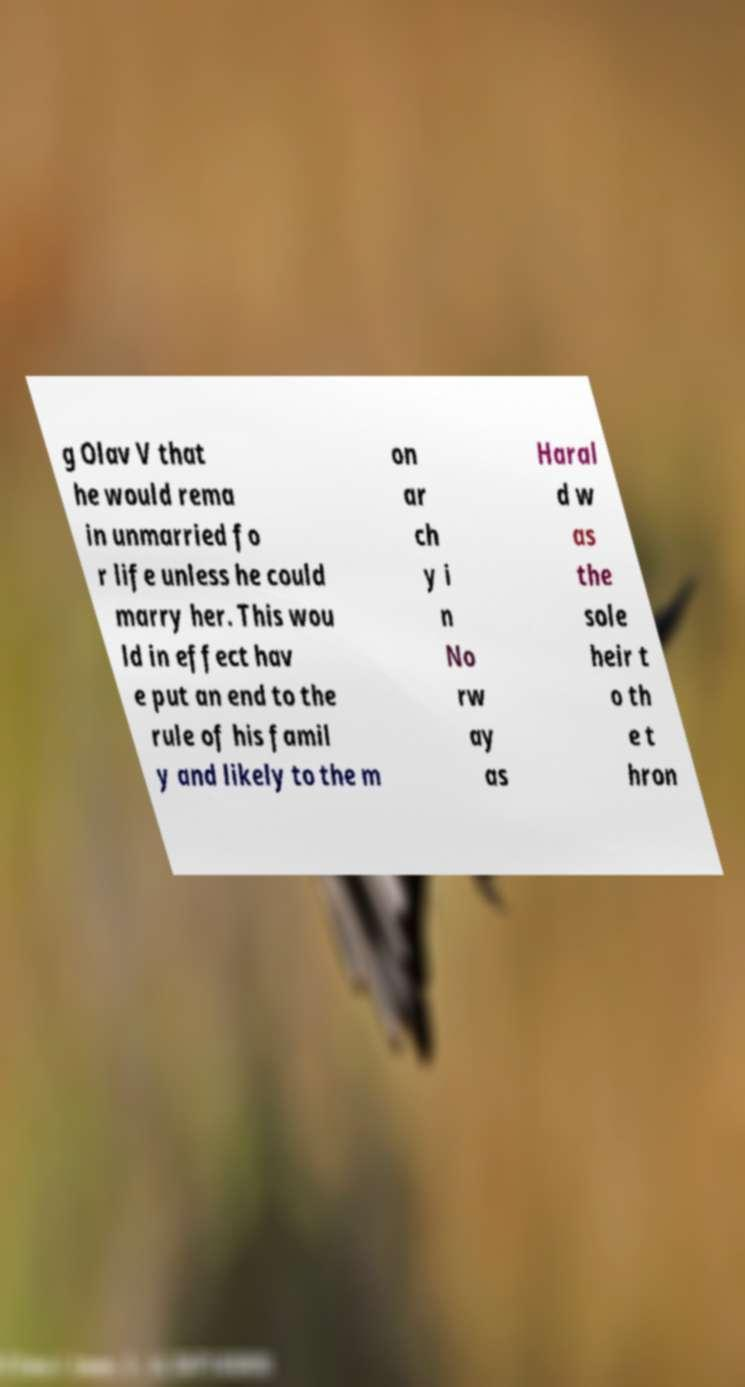There's text embedded in this image that I need extracted. Can you transcribe it verbatim? g Olav V that he would rema in unmarried fo r life unless he could marry her. This wou ld in effect hav e put an end to the rule of his famil y and likely to the m on ar ch y i n No rw ay as Haral d w as the sole heir t o th e t hron 